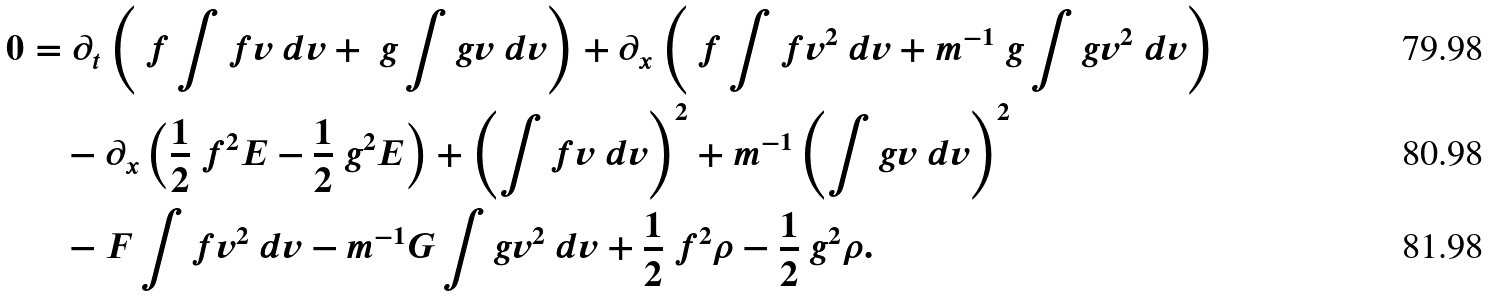<formula> <loc_0><loc_0><loc_500><loc_500>0 & = \partial _ { t } \left ( \ f \int f v \ d v + \ g \int g v \ d v \right ) + \partial _ { x } \left ( \ f \int f v ^ { 2 } \ d v + m ^ { - 1 } \ g \int g v ^ { 2 } \ d v \right ) \\ & \quad - \partial _ { x } \left ( \frac { 1 } { 2 } \ f ^ { 2 } E - \frac { 1 } { 2 } \ g ^ { 2 } E \right ) + \left ( \int f v \ d v \right ) ^ { 2 } + m ^ { - 1 } \left ( \int g v \ d v \right ) ^ { 2 } \\ & \quad - F \int f v ^ { 2 } \ d v - m ^ { - 1 } G \int g v ^ { 2 } \ d v + \frac { 1 } { 2 } \ f ^ { 2 } \rho - \frac { 1 } { 2 } \ g ^ { 2 } \rho .</formula> 